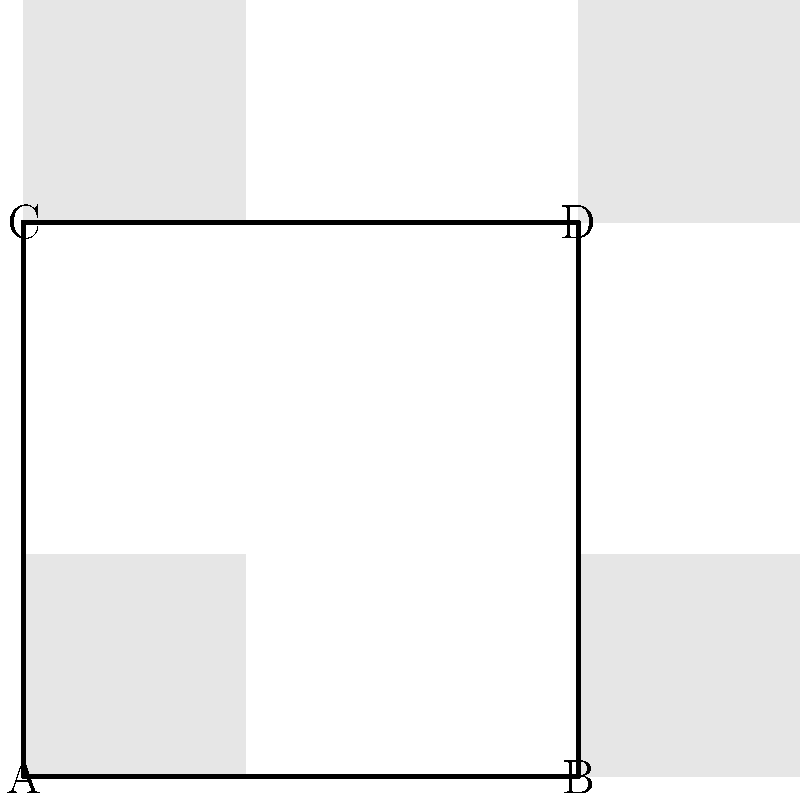A classic film night poster layout consists of four vintage movie posters arranged in a 2x2 grid, as shown in the diagram. How many unique arrangements of these posters are possible if all four posters are different? Let's approach this step-by-step:

1) We have four distinct posters (A, B, C, and D) that need to be arranged in four positions.

2) This is a permutation problem, as the order matters (changing the position of posters creates a new arrangement).

3) For the first position, we have 4 choices of posters.

4) After placing the first poster, we have 3 choices for the second position.

5) For the third position, we're left with 2 choices.

6) For the last position, we only have 1 poster left to place.

7) According to the multiplication principle, the total number of possible arrangements is:

   $$ 4 \times 3 \times 2 \times 1 = 24 $$

8) This is also known as 4 factorial, denoted as $4!$.

Therefore, there are 24 unique ways to arrange the four vintage movie posters in the 2x2 grid layout.
Answer: 24 